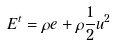Convert formula to latex. <formula><loc_0><loc_0><loc_500><loc_500>E ^ { t } = \rho e + \rho \frac { 1 } { 2 } u ^ { 2 }</formula> 